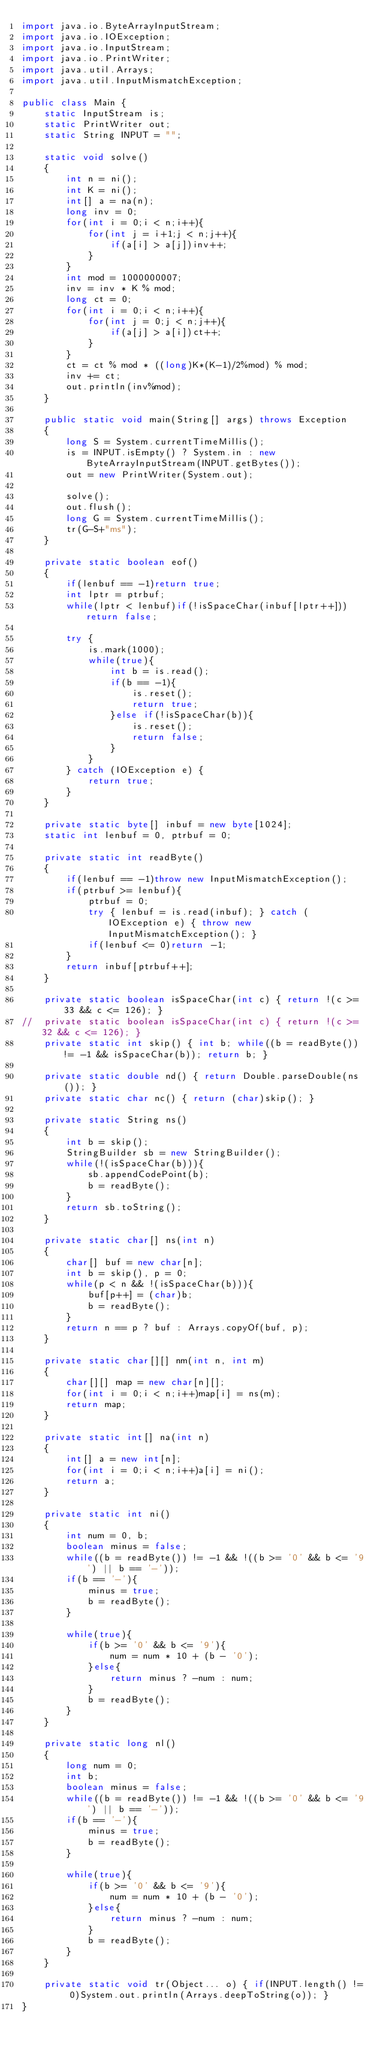<code> <loc_0><loc_0><loc_500><loc_500><_Java_>import java.io.ByteArrayInputStream;
import java.io.IOException;
import java.io.InputStream;
import java.io.PrintWriter;
import java.util.Arrays;
import java.util.InputMismatchException;

public class Main {
	static InputStream is;
	static PrintWriter out;
	static String INPUT = "";
	
	static void solve()
	{
		int n = ni();
		int K = ni();
		int[] a = na(n);
		long inv = 0;
		for(int i = 0;i < n;i++){
			for(int j = i+1;j < n;j++){
				if(a[i] > a[j])inv++;
			}
		}
		int mod = 1000000007;
		inv = inv * K % mod;
		long ct = 0;
		for(int i = 0;i < n;i++){
			for(int j = 0;j < n;j++){
				if(a[j] > a[i])ct++;
			}
		}
		ct = ct % mod * ((long)K*(K-1)/2%mod) % mod;
		inv += ct;
		out.println(inv%mod);
	}
	
	public static void main(String[] args) throws Exception
	{
		long S = System.currentTimeMillis();
		is = INPUT.isEmpty() ? System.in : new ByteArrayInputStream(INPUT.getBytes());
		out = new PrintWriter(System.out);
		
		solve();
		out.flush();
		long G = System.currentTimeMillis();
		tr(G-S+"ms");
	}
	
	private static boolean eof()
	{
		if(lenbuf == -1)return true;
		int lptr = ptrbuf;
		while(lptr < lenbuf)if(!isSpaceChar(inbuf[lptr++]))return false;
		
		try {
			is.mark(1000);
			while(true){
				int b = is.read();
				if(b == -1){
					is.reset();
					return true;
				}else if(!isSpaceChar(b)){
					is.reset();
					return false;
				}
			}
		} catch (IOException e) {
			return true;
		}
	}
	
	private static byte[] inbuf = new byte[1024];
	static int lenbuf = 0, ptrbuf = 0;
	
	private static int readByte()
	{
		if(lenbuf == -1)throw new InputMismatchException();
		if(ptrbuf >= lenbuf){
			ptrbuf = 0;
			try { lenbuf = is.read(inbuf); } catch (IOException e) { throw new InputMismatchException(); }
			if(lenbuf <= 0)return -1;
		}
		return inbuf[ptrbuf++];
	}
	
	private static boolean isSpaceChar(int c) { return !(c >= 33 && c <= 126); }
//	private static boolean isSpaceChar(int c) { return !(c >= 32 && c <= 126); }
	private static int skip() { int b; while((b = readByte()) != -1 && isSpaceChar(b)); return b; }
	
	private static double nd() { return Double.parseDouble(ns()); }
	private static char nc() { return (char)skip(); }
	
	private static String ns()
	{
		int b = skip();
		StringBuilder sb = new StringBuilder();
		while(!(isSpaceChar(b))){
			sb.appendCodePoint(b);
			b = readByte();
		}
		return sb.toString();
	}
	
	private static char[] ns(int n)
	{
		char[] buf = new char[n];
		int b = skip(), p = 0;
		while(p < n && !(isSpaceChar(b))){
			buf[p++] = (char)b;
			b = readByte();
		}
		return n == p ? buf : Arrays.copyOf(buf, p);
	}
	
	private static char[][] nm(int n, int m)
	{
		char[][] map = new char[n][];
		for(int i = 0;i < n;i++)map[i] = ns(m);
		return map;
	}
	
	private static int[] na(int n)
	{
		int[] a = new int[n];
		for(int i = 0;i < n;i++)a[i] = ni();
		return a;
	}
	
	private static int ni()
	{
		int num = 0, b;
		boolean minus = false;
		while((b = readByte()) != -1 && !((b >= '0' && b <= '9') || b == '-'));
		if(b == '-'){
			minus = true;
			b = readByte();
		}
		
		while(true){
			if(b >= '0' && b <= '9'){
				num = num * 10 + (b - '0');
			}else{
				return minus ? -num : num;
			}
			b = readByte();
		}
	}
	
	private static long nl()
	{
		long num = 0;
		int b;
		boolean minus = false;
		while((b = readByte()) != -1 && !((b >= '0' && b <= '9') || b == '-'));
		if(b == '-'){
			minus = true;
			b = readByte();
		}
		
		while(true){
			if(b >= '0' && b <= '9'){
				num = num * 10 + (b - '0');
			}else{
				return minus ? -num : num;
			}
			b = readByte();
		}
	}
	
	private static void tr(Object... o) { if(INPUT.length() != 0)System.out.println(Arrays.deepToString(o)); }
}
</code> 